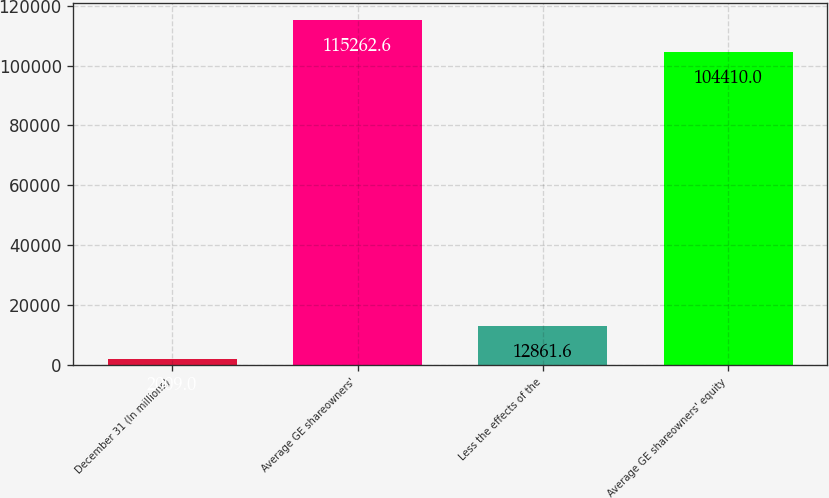Convert chart. <chart><loc_0><loc_0><loc_500><loc_500><bar_chart><fcel>December 31 (In millions)<fcel>Average GE shareowners'<fcel>Less the effects of the<fcel>Average GE shareowners' equity<nl><fcel>2009<fcel>115263<fcel>12861.6<fcel>104410<nl></chart> 